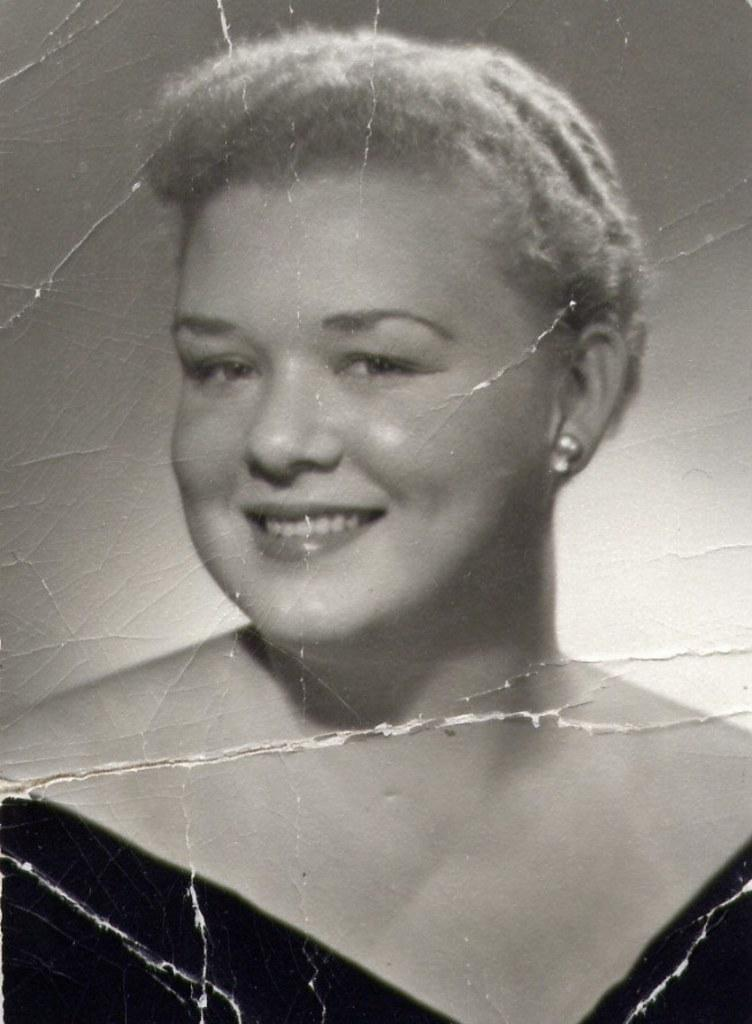What is the main subject of the image? There is a person in the image. What color scheme is used in the image? The image is in black and white. What day of the week is depicted in the image? The image does not depict a specific day of the week, as it is in black and white and does not contain any text or context to suggest a particular day. 